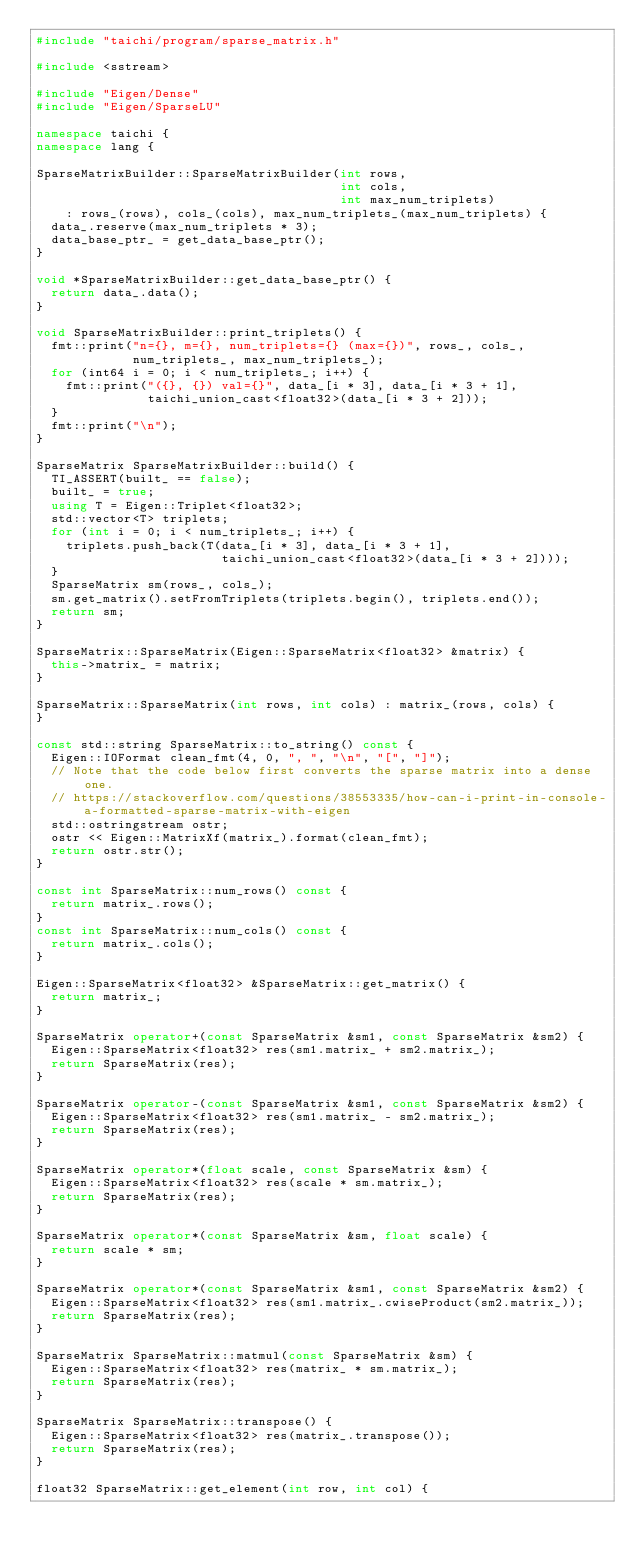<code> <loc_0><loc_0><loc_500><loc_500><_C++_>#include "taichi/program/sparse_matrix.h"

#include <sstream>

#include "Eigen/Dense"
#include "Eigen/SparseLU"

namespace taichi {
namespace lang {

SparseMatrixBuilder::SparseMatrixBuilder(int rows,
                                         int cols,
                                         int max_num_triplets)
    : rows_(rows), cols_(cols), max_num_triplets_(max_num_triplets) {
  data_.reserve(max_num_triplets * 3);
  data_base_ptr_ = get_data_base_ptr();
}

void *SparseMatrixBuilder::get_data_base_ptr() {
  return data_.data();
}

void SparseMatrixBuilder::print_triplets() {
  fmt::print("n={}, m={}, num_triplets={} (max={})", rows_, cols_,
             num_triplets_, max_num_triplets_);
  for (int64 i = 0; i < num_triplets_; i++) {
    fmt::print("({}, {}) val={}", data_[i * 3], data_[i * 3 + 1],
               taichi_union_cast<float32>(data_[i * 3 + 2]));
  }
  fmt::print("\n");
}

SparseMatrix SparseMatrixBuilder::build() {
  TI_ASSERT(built_ == false);
  built_ = true;
  using T = Eigen::Triplet<float32>;
  std::vector<T> triplets;
  for (int i = 0; i < num_triplets_; i++) {
    triplets.push_back(T(data_[i * 3], data_[i * 3 + 1],
                         taichi_union_cast<float32>(data_[i * 3 + 2])));
  }
  SparseMatrix sm(rows_, cols_);
  sm.get_matrix().setFromTriplets(triplets.begin(), triplets.end());
  return sm;
}

SparseMatrix::SparseMatrix(Eigen::SparseMatrix<float32> &matrix) {
  this->matrix_ = matrix;
}

SparseMatrix::SparseMatrix(int rows, int cols) : matrix_(rows, cols) {
}

const std::string SparseMatrix::to_string() const {
  Eigen::IOFormat clean_fmt(4, 0, ", ", "\n", "[", "]");
  // Note that the code below first converts the sparse matrix into a dense one.
  // https://stackoverflow.com/questions/38553335/how-can-i-print-in-console-a-formatted-sparse-matrix-with-eigen
  std::ostringstream ostr;
  ostr << Eigen::MatrixXf(matrix_).format(clean_fmt);
  return ostr.str();
}

const int SparseMatrix::num_rows() const {
  return matrix_.rows();
}
const int SparseMatrix::num_cols() const {
  return matrix_.cols();
}

Eigen::SparseMatrix<float32> &SparseMatrix::get_matrix() {
  return matrix_;
}

SparseMatrix operator+(const SparseMatrix &sm1, const SparseMatrix &sm2) {
  Eigen::SparseMatrix<float32> res(sm1.matrix_ + sm2.matrix_);
  return SparseMatrix(res);
}

SparseMatrix operator-(const SparseMatrix &sm1, const SparseMatrix &sm2) {
  Eigen::SparseMatrix<float32> res(sm1.matrix_ - sm2.matrix_);
  return SparseMatrix(res);
}

SparseMatrix operator*(float scale, const SparseMatrix &sm) {
  Eigen::SparseMatrix<float32> res(scale * sm.matrix_);
  return SparseMatrix(res);
}

SparseMatrix operator*(const SparseMatrix &sm, float scale) {
  return scale * sm;
}

SparseMatrix operator*(const SparseMatrix &sm1, const SparseMatrix &sm2) {
  Eigen::SparseMatrix<float32> res(sm1.matrix_.cwiseProduct(sm2.matrix_));
  return SparseMatrix(res);
}

SparseMatrix SparseMatrix::matmul(const SparseMatrix &sm) {
  Eigen::SparseMatrix<float32> res(matrix_ * sm.matrix_);
  return SparseMatrix(res);
}

SparseMatrix SparseMatrix::transpose() {
  Eigen::SparseMatrix<float32> res(matrix_.transpose());
  return SparseMatrix(res);
}

float32 SparseMatrix::get_element(int row, int col) {</code> 